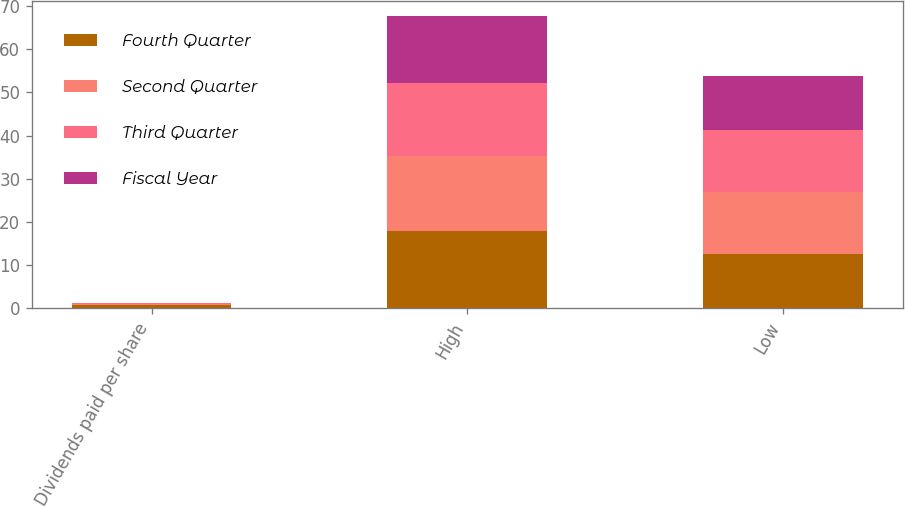Convert chart. <chart><loc_0><loc_0><loc_500><loc_500><stacked_bar_chart><ecel><fcel>Dividends paid per share<fcel>High<fcel>Low<nl><fcel>Fourth Quarter<fcel>0.7<fcel>17.75<fcel>12.54<nl><fcel>Second Quarter<fcel>0.2<fcel>17.46<fcel>14.35<nl><fcel>Third Quarter<fcel>0.2<fcel>17.09<fcel>14.41<nl><fcel>Fiscal Year<fcel>0.15<fcel>15.52<fcel>12.54<nl></chart> 